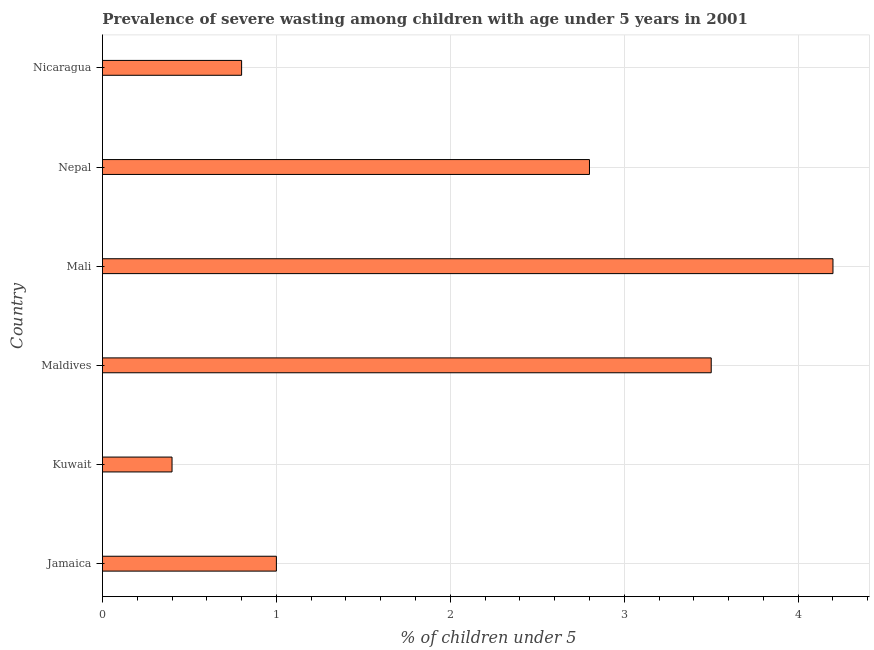What is the title of the graph?
Your answer should be compact. Prevalence of severe wasting among children with age under 5 years in 2001. What is the label or title of the X-axis?
Make the answer very short.  % of children under 5. What is the prevalence of severe wasting in Kuwait?
Provide a short and direct response. 0.4. Across all countries, what is the maximum prevalence of severe wasting?
Your response must be concise. 4.2. Across all countries, what is the minimum prevalence of severe wasting?
Provide a short and direct response. 0.4. In which country was the prevalence of severe wasting maximum?
Your answer should be very brief. Mali. In which country was the prevalence of severe wasting minimum?
Give a very brief answer. Kuwait. What is the sum of the prevalence of severe wasting?
Provide a short and direct response. 12.7. What is the average prevalence of severe wasting per country?
Ensure brevity in your answer.  2.12. What is the median prevalence of severe wasting?
Make the answer very short. 1.9. What is the ratio of the prevalence of severe wasting in Jamaica to that in Maldives?
Keep it short and to the point. 0.29. Is the difference between the prevalence of severe wasting in Jamaica and Nicaragua greater than the difference between any two countries?
Provide a succinct answer. No. What is the difference between the highest and the second highest prevalence of severe wasting?
Offer a very short reply. 0.7. In how many countries, is the prevalence of severe wasting greater than the average prevalence of severe wasting taken over all countries?
Offer a terse response. 3. Are all the bars in the graph horizontal?
Your answer should be very brief. Yes. How many countries are there in the graph?
Provide a succinct answer. 6. What is the  % of children under 5 in Kuwait?
Provide a short and direct response. 0.4. What is the  % of children under 5 in Mali?
Keep it short and to the point. 4.2. What is the  % of children under 5 of Nepal?
Make the answer very short. 2.8. What is the  % of children under 5 of Nicaragua?
Keep it short and to the point. 0.8. What is the difference between the  % of children under 5 in Jamaica and Kuwait?
Your answer should be compact. 0.6. What is the difference between the  % of children under 5 in Jamaica and Maldives?
Your response must be concise. -2.5. What is the difference between the  % of children under 5 in Jamaica and Nepal?
Offer a terse response. -1.8. What is the difference between the  % of children under 5 in Jamaica and Nicaragua?
Give a very brief answer. 0.2. What is the difference between the  % of children under 5 in Kuwait and Nepal?
Your answer should be compact. -2.4. What is the difference between the  % of children under 5 in Maldives and Mali?
Provide a succinct answer. -0.7. What is the difference between the  % of children under 5 in Maldives and Nepal?
Give a very brief answer. 0.7. What is the difference between the  % of children under 5 in Mali and Nepal?
Offer a terse response. 1.4. What is the difference between the  % of children under 5 in Mali and Nicaragua?
Provide a short and direct response. 3.4. What is the ratio of the  % of children under 5 in Jamaica to that in Kuwait?
Your response must be concise. 2.5. What is the ratio of the  % of children under 5 in Jamaica to that in Maldives?
Give a very brief answer. 0.29. What is the ratio of the  % of children under 5 in Jamaica to that in Mali?
Offer a terse response. 0.24. What is the ratio of the  % of children under 5 in Jamaica to that in Nepal?
Your answer should be very brief. 0.36. What is the ratio of the  % of children under 5 in Kuwait to that in Maldives?
Give a very brief answer. 0.11. What is the ratio of the  % of children under 5 in Kuwait to that in Mali?
Provide a short and direct response. 0.1. What is the ratio of the  % of children under 5 in Kuwait to that in Nepal?
Your answer should be compact. 0.14. What is the ratio of the  % of children under 5 in Kuwait to that in Nicaragua?
Your response must be concise. 0.5. What is the ratio of the  % of children under 5 in Maldives to that in Mali?
Offer a very short reply. 0.83. What is the ratio of the  % of children under 5 in Maldives to that in Nepal?
Ensure brevity in your answer.  1.25. What is the ratio of the  % of children under 5 in Maldives to that in Nicaragua?
Make the answer very short. 4.38. What is the ratio of the  % of children under 5 in Mali to that in Nepal?
Make the answer very short. 1.5. What is the ratio of the  % of children under 5 in Mali to that in Nicaragua?
Offer a very short reply. 5.25. What is the ratio of the  % of children under 5 in Nepal to that in Nicaragua?
Ensure brevity in your answer.  3.5. 